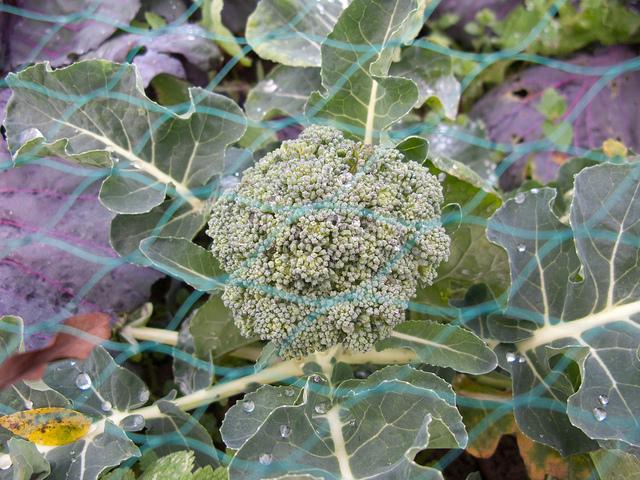What is planted in the garden?
Be succinct. Broccoli. What are the purple objects?
Concise answer only. Leaves. What color is the chain-link fence?
Give a very brief answer. Green. 